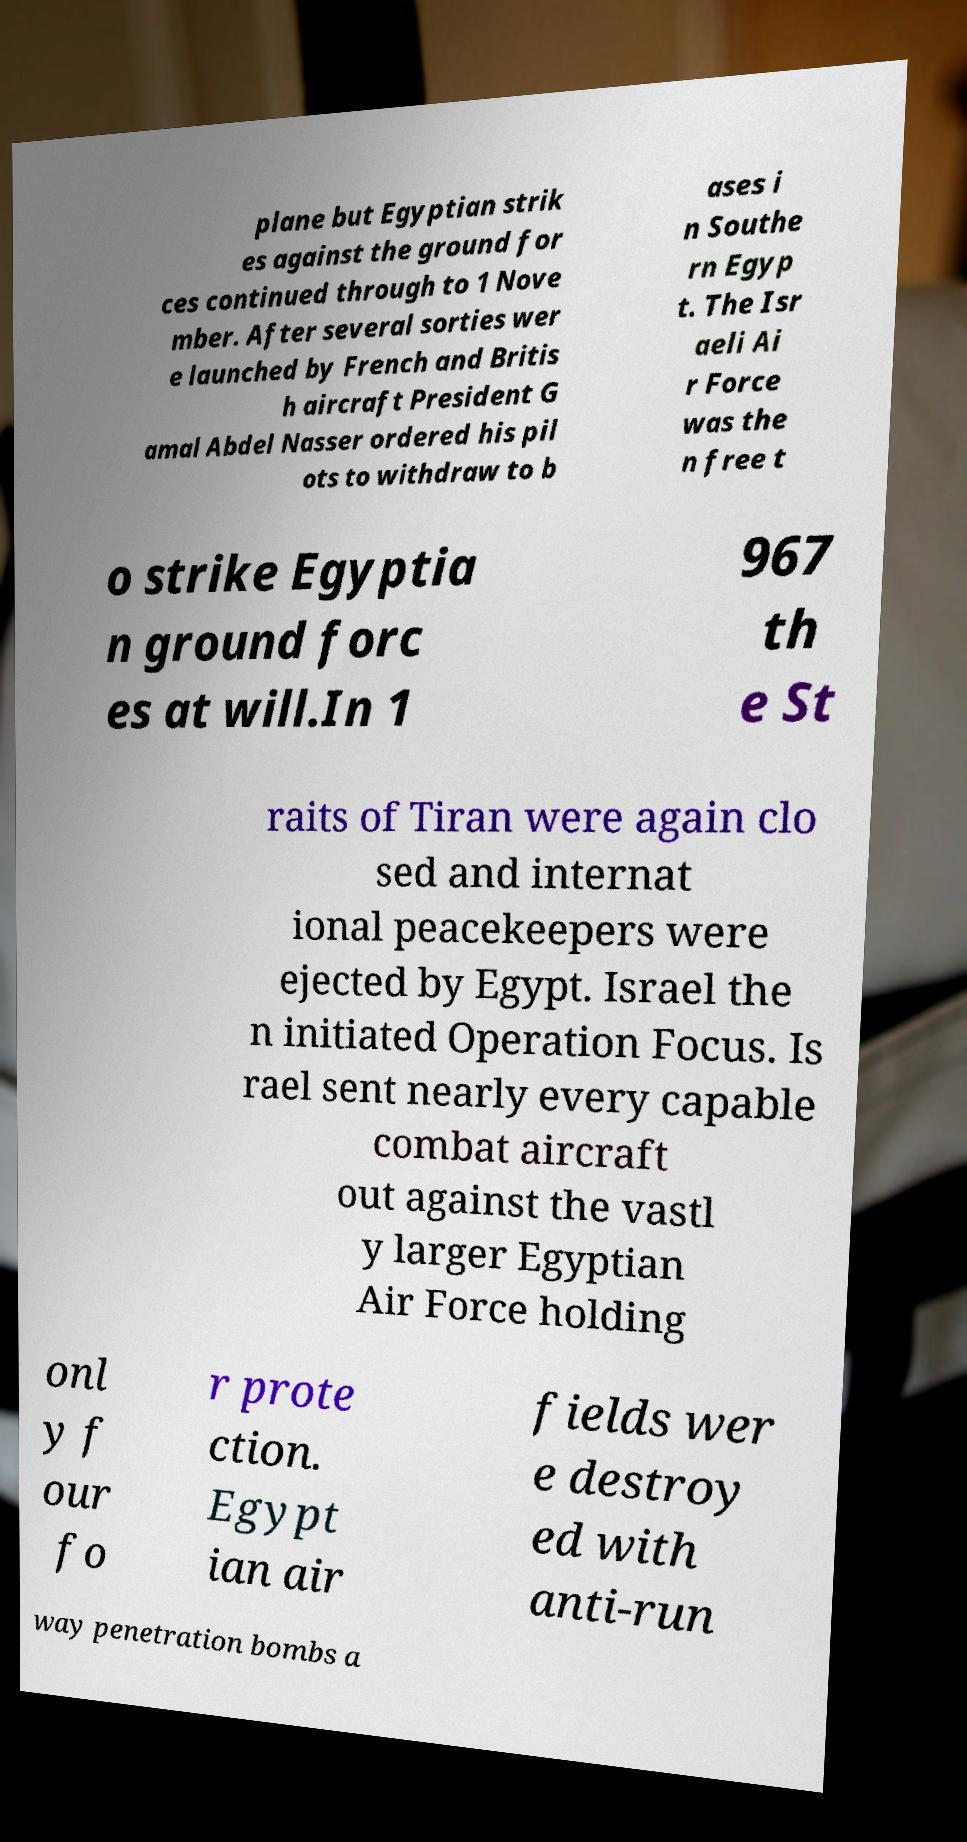Could you extract and type out the text from this image? plane but Egyptian strik es against the ground for ces continued through to 1 Nove mber. After several sorties wer e launched by French and Britis h aircraft President G amal Abdel Nasser ordered his pil ots to withdraw to b ases i n Southe rn Egyp t. The Isr aeli Ai r Force was the n free t o strike Egyptia n ground forc es at will.In 1 967 th e St raits of Tiran were again clo sed and internat ional peacekeepers were ejected by Egypt. Israel the n initiated Operation Focus. Is rael sent nearly every capable combat aircraft out against the vastl y larger Egyptian Air Force holding onl y f our fo r prote ction. Egypt ian air fields wer e destroy ed with anti-run way penetration bombs a 